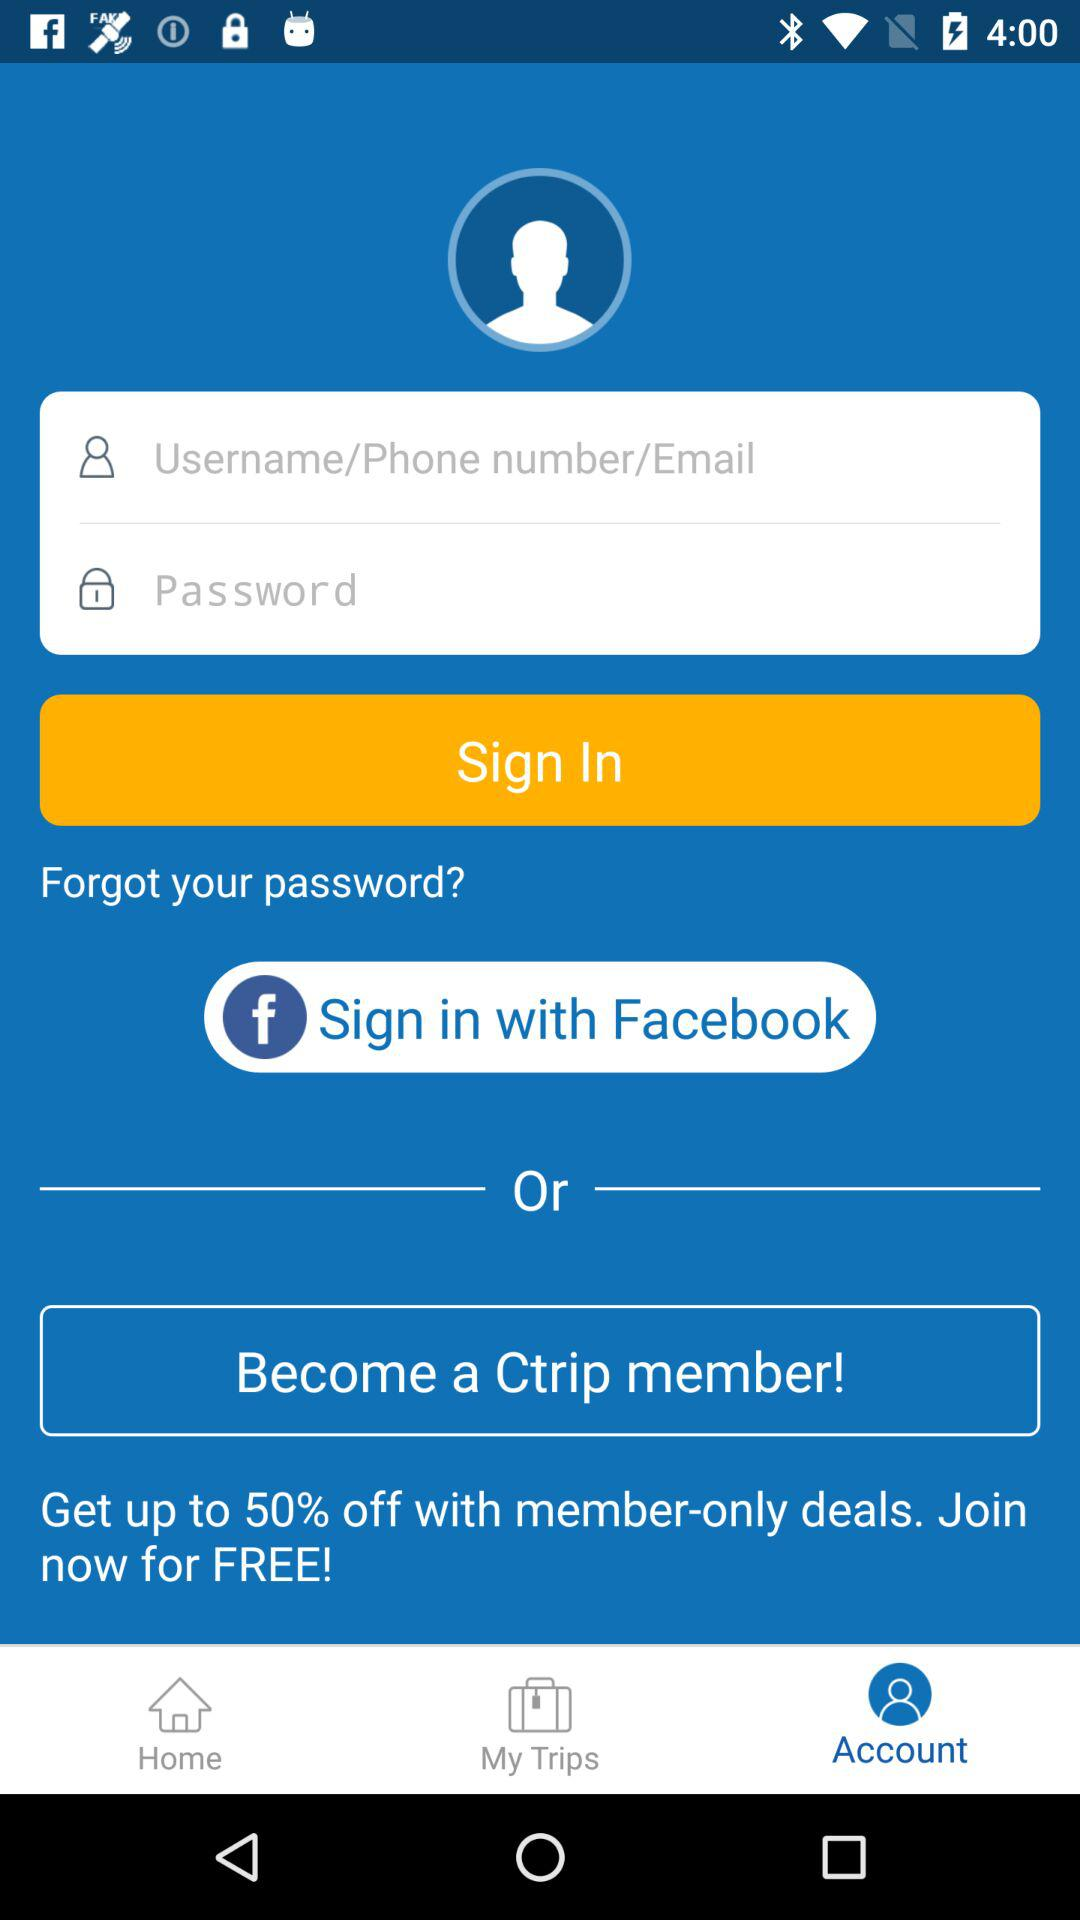How much is the discount on member-only deals? The discount is up to 50%. 